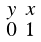<formula> <loc_0><loc_0><loc_500><loc_500>\begin{smallmatrix} y & x \\ 0 & 1 \\ \end{smallmatrix}</formula> 